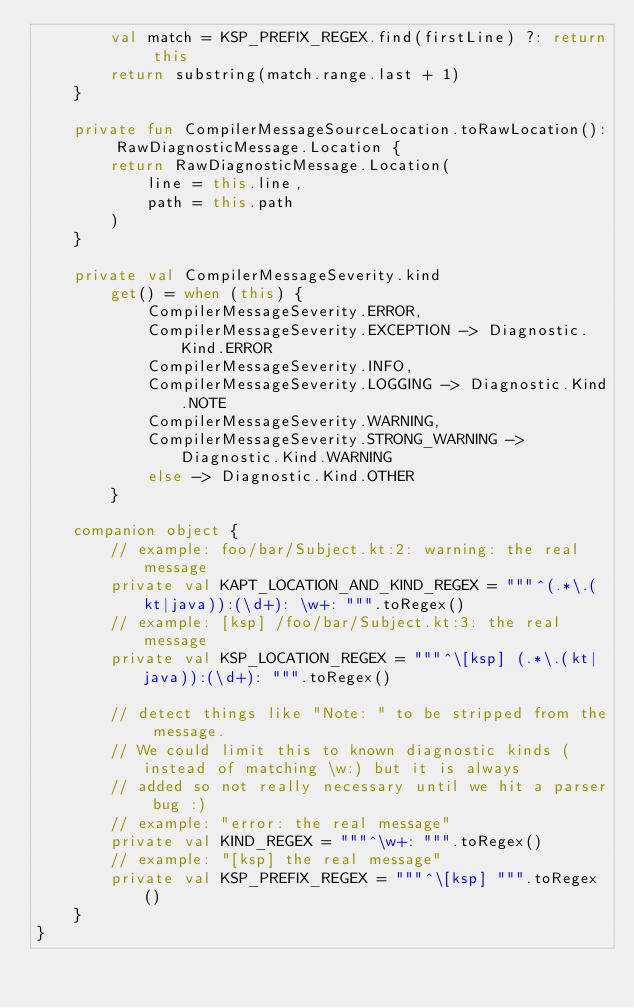Convert code to text. <code><loc_0><loc_0><loc_500><loc_500><_Kotlin_>        val match = KSP_PREFIX_REGEX.find(firstLine) ?: return this
        return substring(match.range.last + 1)
    }

    private fun CompilerMessageSourceLocation.toRawLocation(): RawDiagnosticMessage.Location {
        return RawDiagnosticMessage.Location(
            line = this.line,
            path = this.path
        )
    }

    private val CompilerMessageSeverity.kind
        get() = when (this) {
            CompilerMessageSeverity.ERROR,
            CompilerMessageSeverity.EXCEPTION -> Diagnostic.Kind.ERROR
            CompilerMessageSeverity.INFO,
            CompilerMessageSeverity.LOGGING -> Diagnostic.Kind.NOTE
            CompilerMessageSeverity.WARNING,
            CompilerMessageSeverity.STRONG_WARNING -> Diagnostic.Kind.WARNING
            else -> Diagnostic.Kind.OTHER
        }

    companion object {
        // example: foo/bar/Subject.kt:2: warning: the real message
        private val KAPT_LOCATION_AND_KIND_REGEX = """^(.*\.(kt|java)):(\d+): \w+: """.toRegex()
        // example: [ksp] /foo/bar/Subject.kt:3: the real message
        private val KSP_LOCATION_REGEX = """^\[ksp] (.*\.(kt|java)):(\d+): """.toRegex()

        // detect things like "Note: " to be stripped from the message.
        // We could limit this to known diagnostic kinds (instead of matching \w:) but it is always
        // added so not really necessary until we hit a parser bug :)
        // example: "error: the real message"
        private val KIND_REGEX = """^\w+: """.toRegex()
        // example: "[ksp] the real message"
        private val KSP_PREFIX_REGEX = """^\[ksp] """.toRegex()
    }
}</code> 